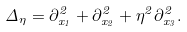<formula> <loc_0><loc_0><loc_500><loc_500>\Delta _ { \eta } = \partial _ { x _ { 1 } } ^ { 2 } + \partial _ { x _ { 2 } } ^ { 2 } + \eta ^ { 2 } \partial _ { x _ { 3 } } ^ { 2 } .</formula> 